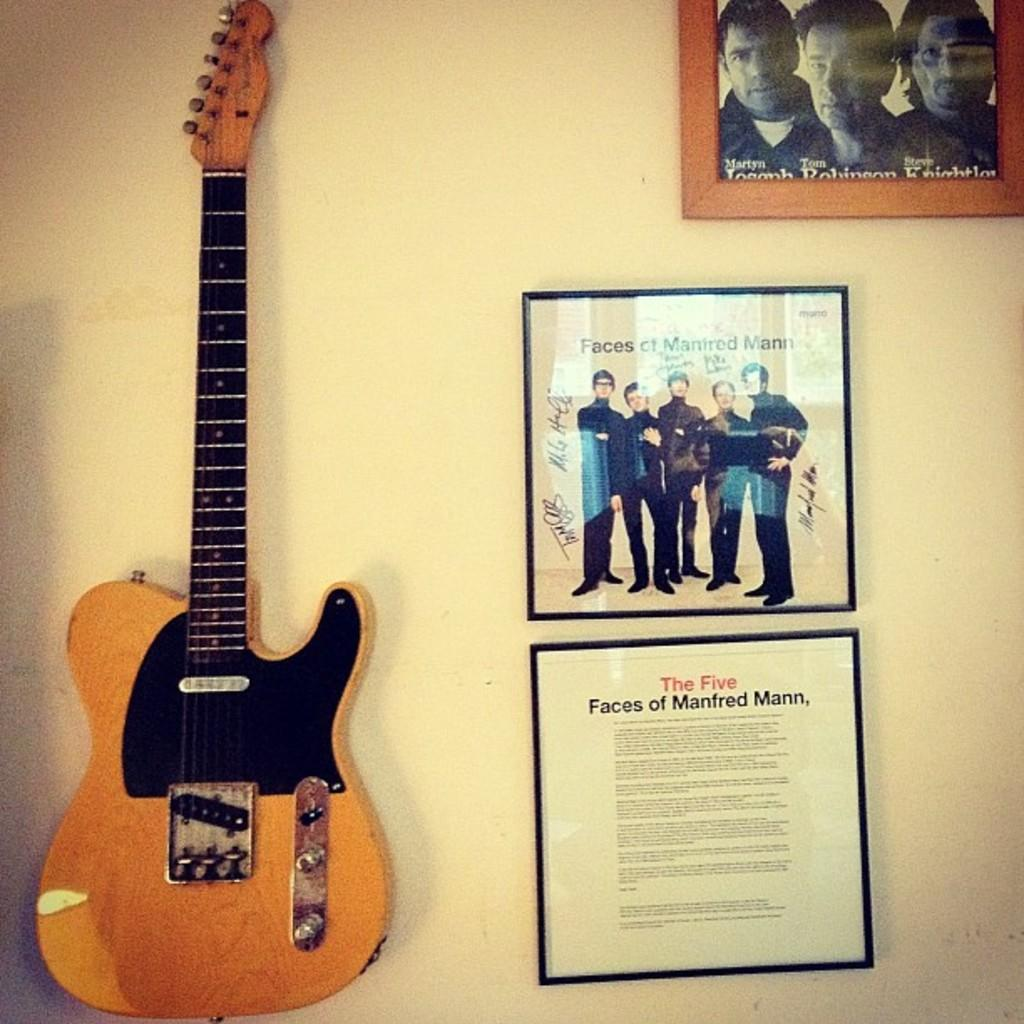What musical instrument is attached to the wall in the image? There is a guitar attached to the wall in the image. What other items are attached to the wall in the image? There are photo frames attached to the wall in the image. What type of marble is used for the floor in the image? There is no information about the floor in the image, and no marble is mentioned or visible. 